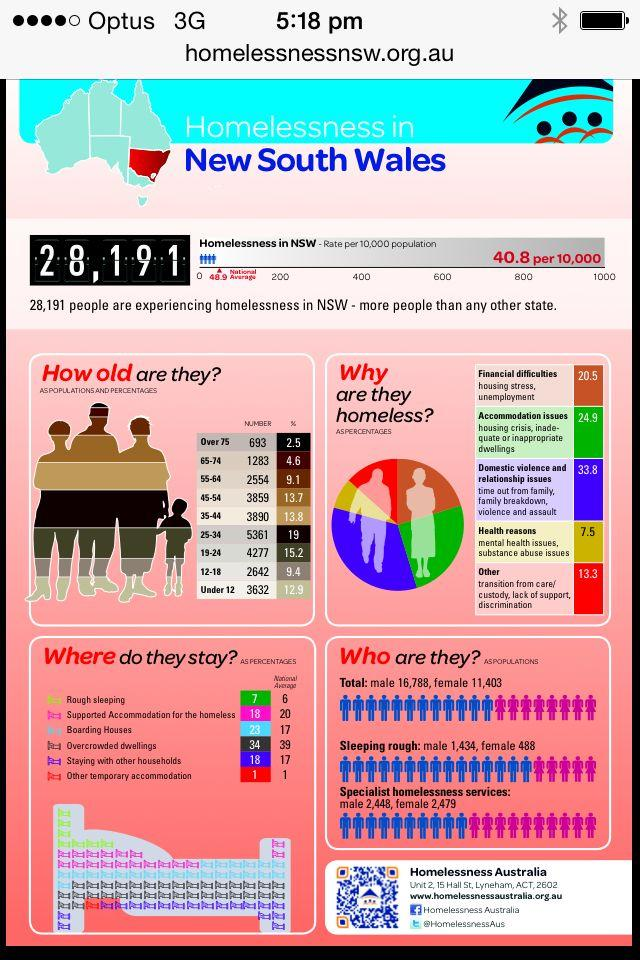Indicate a few pertinent items in this graphic. The national average of homeless people living in overcrowded dwellings in New South Wales (NSW) is 39%. Approximately 7.5% of the population in New South Wales (NSW), Australia, are homeless due to health reasons. There is a significant percentage of homelessness among individuals aged 75 years and older in New South Wales (NSW). Specifically, the figure is 2.5%. In New South Wales, approximately 20.5% of people experience homelessness due to financial difficulties. In the age group of 65-74 years, there were 1,283 individuals who were homeless in the state of New South Wales. 